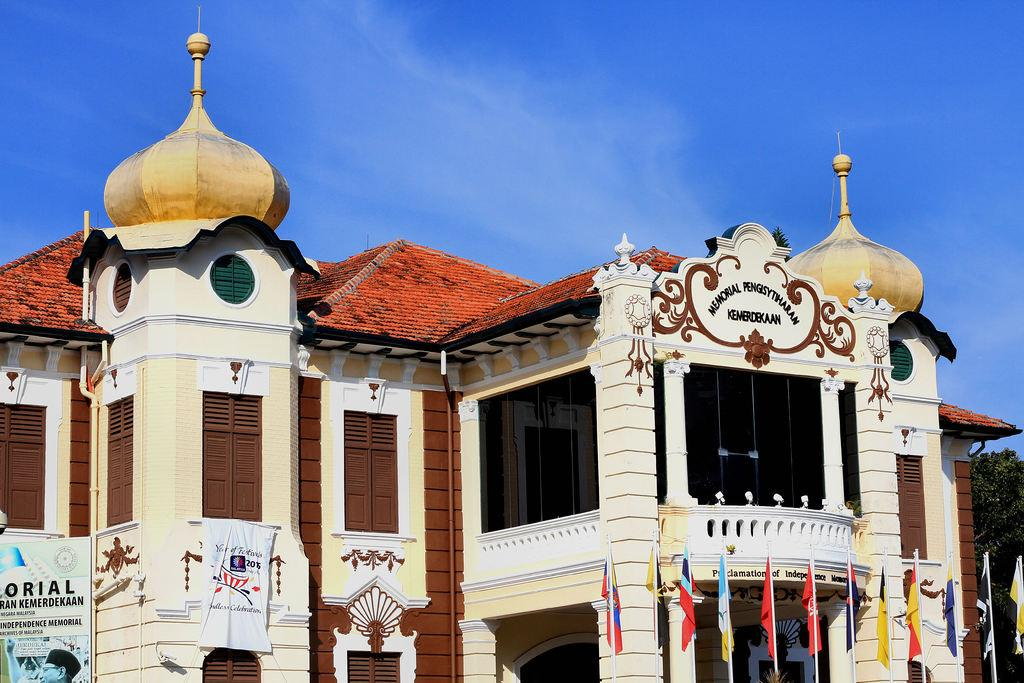What can be seen in the foreground of the image? There are flags and banners in the foreground of the image. What is the main structure in the image? There is a building in the center of the image. What type of vegetation is on the right side of the image? There is a tree on the right side of the image. How would you describe the weather in the image? The sky is sunny, indicating good weather. Can you see any worms crawling on the tree in the image? There are no worms visible in the image; only the tree is present. What type of instrument is being played in the image? There is no instrument being played in the image; the focus is on the flags, building, and tree. 